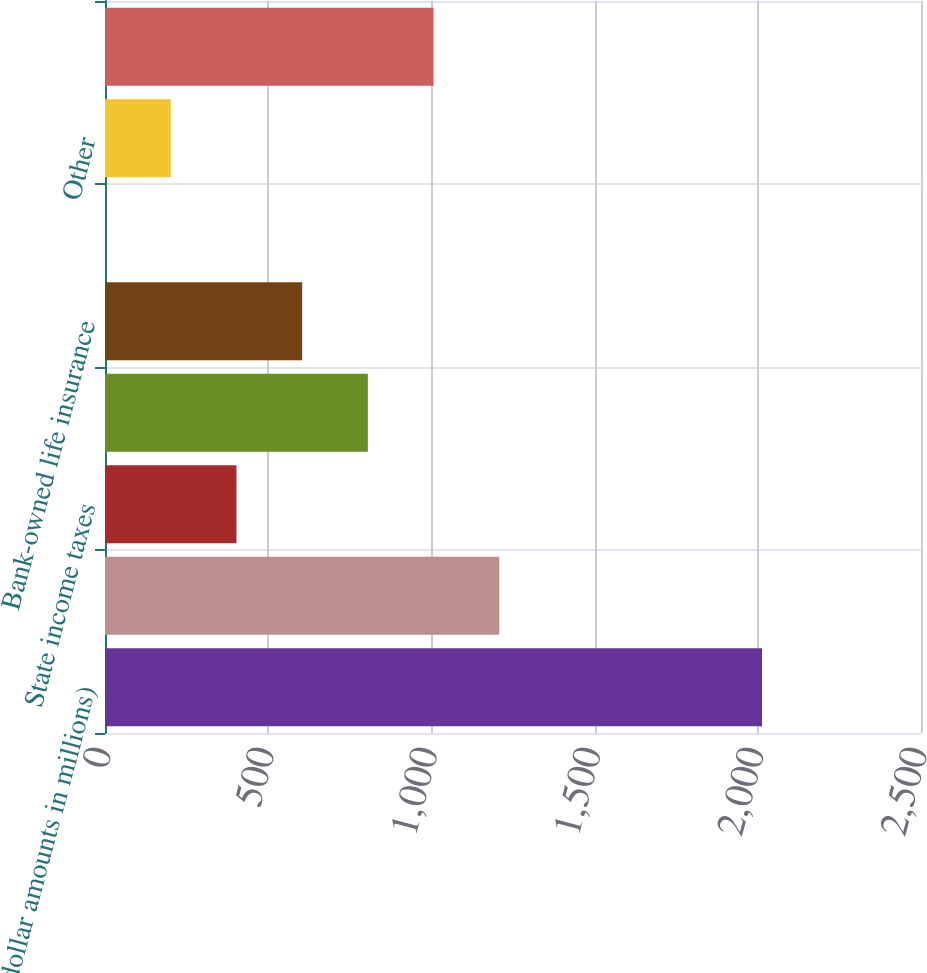Convert chart. <chart><loc_0><loc_0><loc_500><loc_500><bar_chart><fcel>(dollar amounts in millions)<fcel>Tax based on federal statutory<fcel>State income taxes<fcel>Affordable housing and<fcel>Bank-owned life insurance<fcel>Other changes in unrecognized<fcel>Other<fcel>Provision for income taxes<nl><fcel>2013<fcel>1207.88<fcel>402.76<fcel>805.32<fcel>604.04<fcel>0.2<fcel>201.48<fcel>1006.6<nl></chart> 